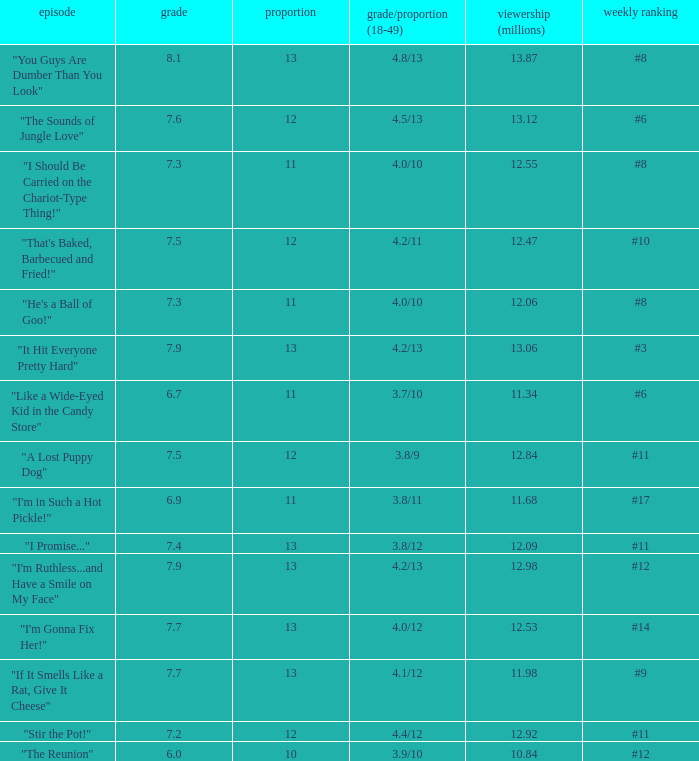What is the average rating for "a lost puppy dog"? 7.5. 